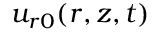Convert formula to latex. <formula><loc_0><loc_0><loc_500><loc_500>u _ { r 0 } ( r , z , t )</formula> 